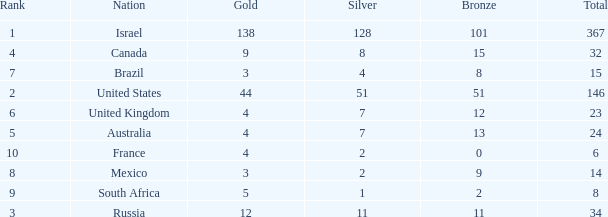What is the maximum number of silvers for a country with fewer than 12 golds and a total less than 8? 2.0. 